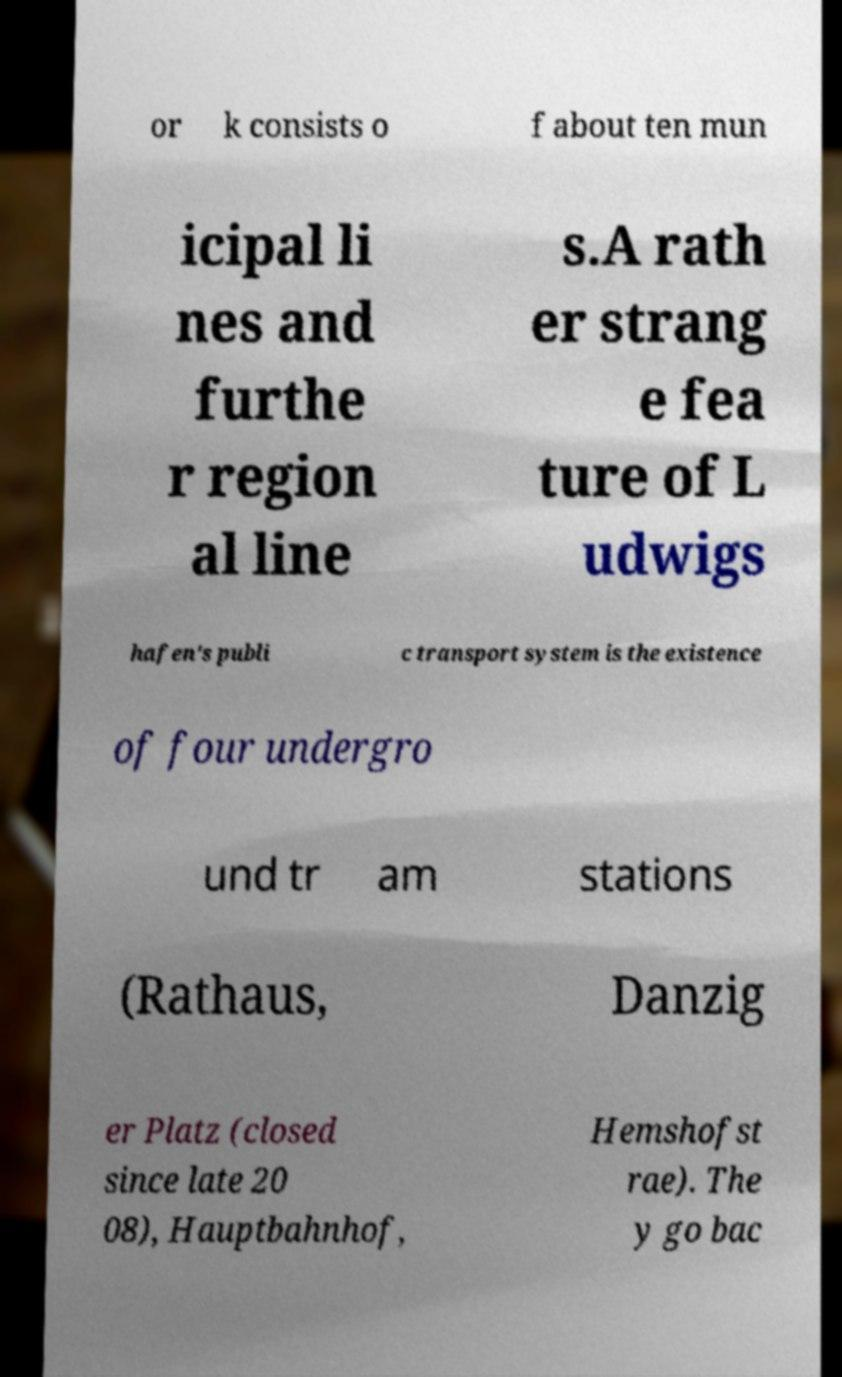Please identify and transcribe the text found in this image. or k consists o f about ten mun icipal li nes and furthe r region al line s.A rath er strang e fea ture of L udwigs hafen's publi c transport system is the existence of four undergro und tr am stations (Rathaus, Danzig er Platz (closed since late 20 08), Hauptbahnhof, Hemshofst rae). The y go bac 